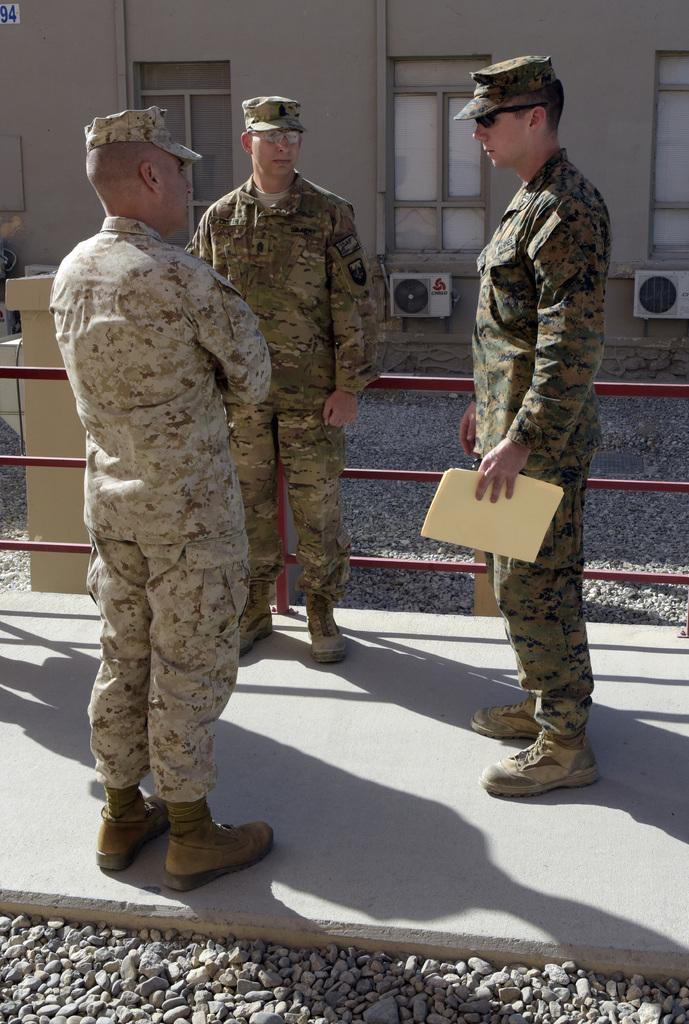Describe this image in one or two sentences. In this image there are three officers standing on road beside the fence, behind them there is a building on which we can see windows and AC ventilators. 